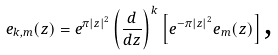<formula> <loc_0><loc_0><loc_500><loc_500>e _ { k , m } ( z ) = e ^ { \pi \left | z \right | ^ { 2 } } \left ( \frac { d } { d z } \right ) ^ { k } \left [ e ^ { - \pi \left | z \right | ^ { 2 } } e _ { m } ( z ) \right ] \text {,}</formula> 